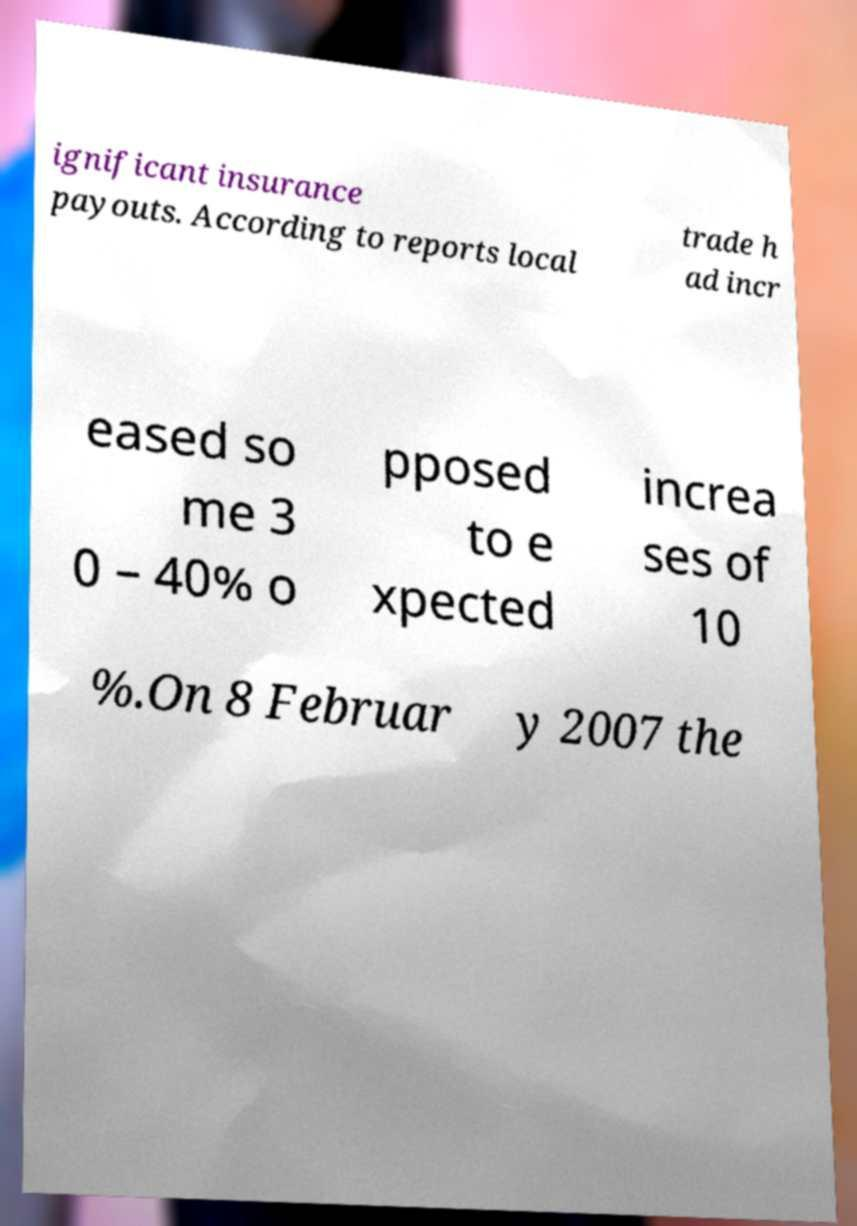I need the written content from this picture converted into text. Can you do that? ignificant insurance payouts. According to reports local trade h ad incr eased so me 3 0 – 40% o pposed to e xpected increa ses of 10 %.On 8 Februar y 2007 the 